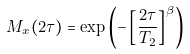<formula> <loc_0><loc_0><loc_500><loc_500>M _ { x } ( 2 \tau ) = \exp \left ( - \left [ \frac { 2 \tau } { T _ { 2 } } \right ] ^ { \beta } \right )</formula> 